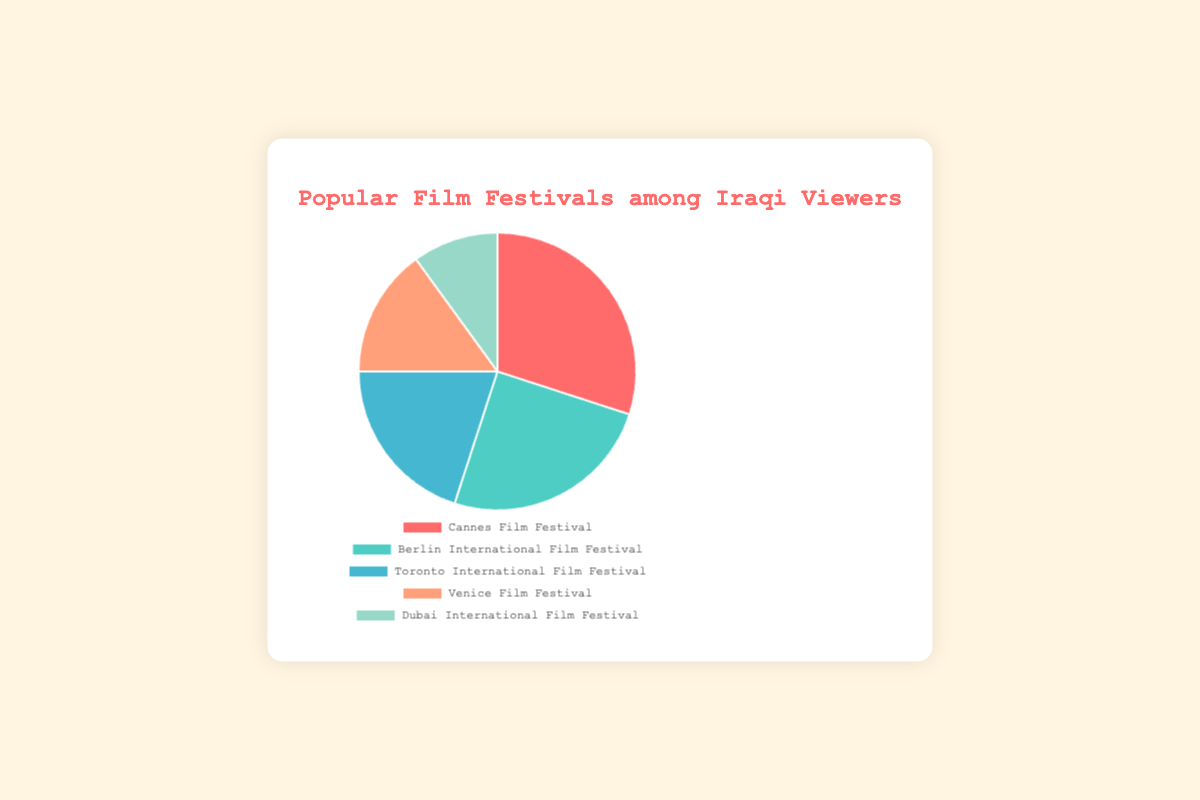Which film festival is the most popular among Iraqi viewers? The Cannes Film Festival occupies the largest section of the pie chart, indicating it is the most popular.
Answer: Cannes Film Festival How many percentage points more popular is the Cannes Film Festival compared to the Berlin International Film Festival? The Cannes Film Festival has 30% whereas the Berlin International Film Festival has 25%. Subtracting the two gives 30% - 25% = 5%.
Answer: 5 What is the combined popularity percentage of the Toronto International Film Festival and the Venice Film Festival? The Toronto International Film Festival has 20% and the Venice Film Festival has 15%. Summing these gives 20% + 15% = 35%.
Answer: 35% Which festival has the smallest proportion in the chart? The Dubai International Film Festival takes up the smallest section of the pie chart.
Answer: Dubai International Film Festival Which festival is represented by the smallest slice of the chart? The Dubai International Film Festival is shown as the smallest slice of the pie chart, which indicates it is the least popular.
Answer: Dubai International Film Festival Is the combined percentage of the Venice and Dubai International Film Festivals greater than the Berlin International Film Festival? The Venice Film Festival has 15% and Dubai has 10%. Combined, they total 25% which is equal to the Berlin International Film Festival's 25%.
Answer: No What color represents the most popular festival? The section labeled "Cannes Film Festival" is colored red in the pie chart.
Answer: Red How does the popularity of the Toronto International Film Festival compare to the Venice Film Festival? The Toronto International Film Festival has a 20% share, while the Venice Film Festival has a 15% share, making Toronto more popular.
Answer: More popular What is the second most popular film festival among Iraqi viewers? The Berlin International Film Festival, representing 25%, is the second largest section after Cannes.
Answer: Berlin International Film Festival What percentage of viewers prefer the Dubai International Film Festival? The Dubai International Film Festival accounts for 10% of the chart.
Answer: 10% 